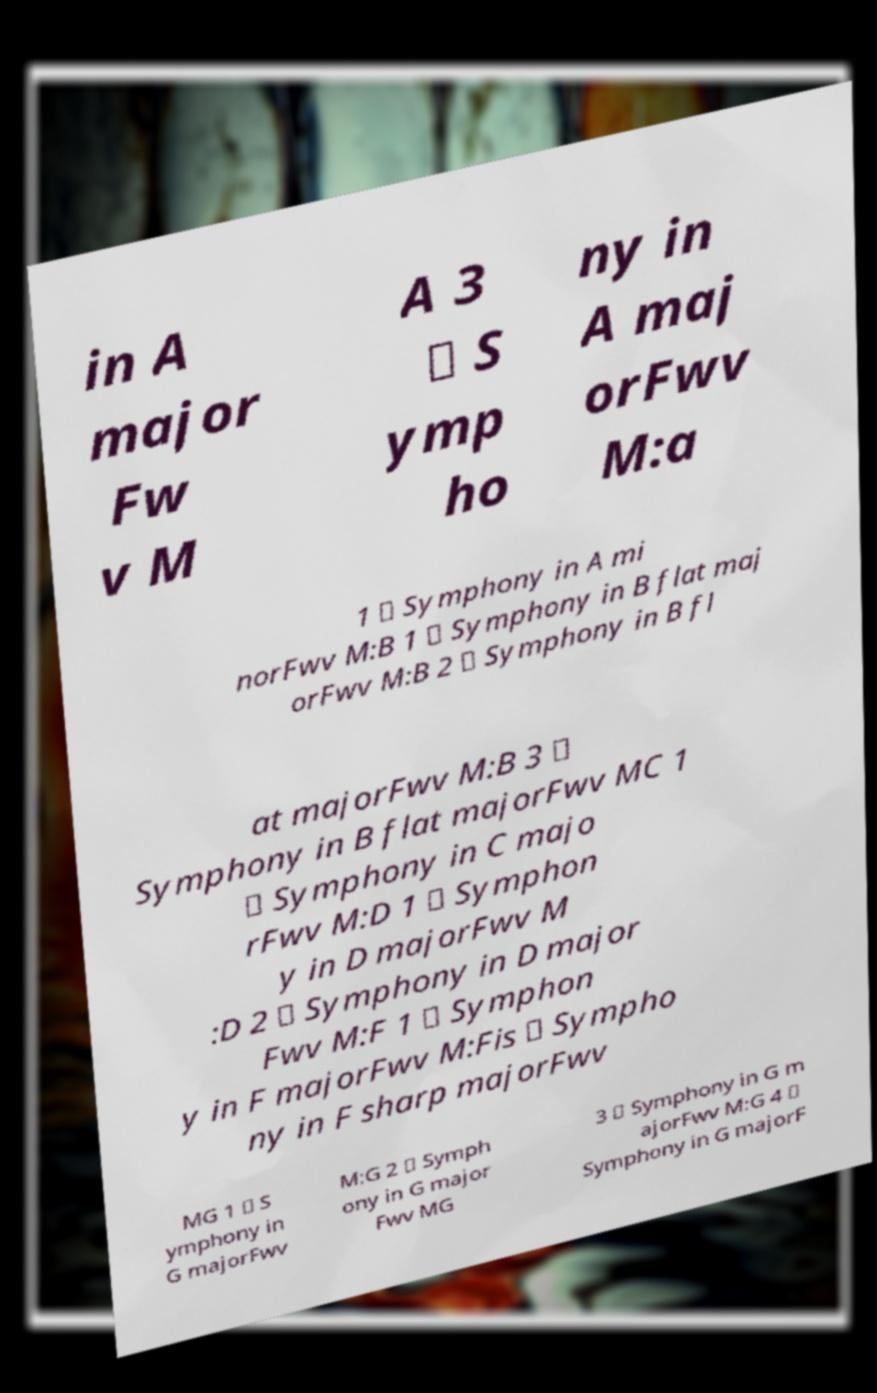Please identify and transcribe the text found in this image. in A major Fw v M A 3 \ S ymp ho ny in A maj orFwv M:a 1 \ Symphony in A mi norFwv M:B 1 \ Symphony in B flat maj orFwv M:B 2 \ Symphony in B fl at majorFwv M:B 3 \ Symphony in B flat majorFwv MC 1 \ Symphony in C majo rFwv M:D 1 \ Symphon y in D majorFwv M :D 2 \ Symphony in D major Fwv M:F 1 \ Symphon y in F majorFwv M:Fis \ Sympho ny in F sharp majorFwv MG 1 \ S ymphony in G majorFwv M:G 2 \ Symph ony in G major Fwv MG 3 \ Symphony in G m ajorFwv M:G 4 \ Symphony in G majorF 